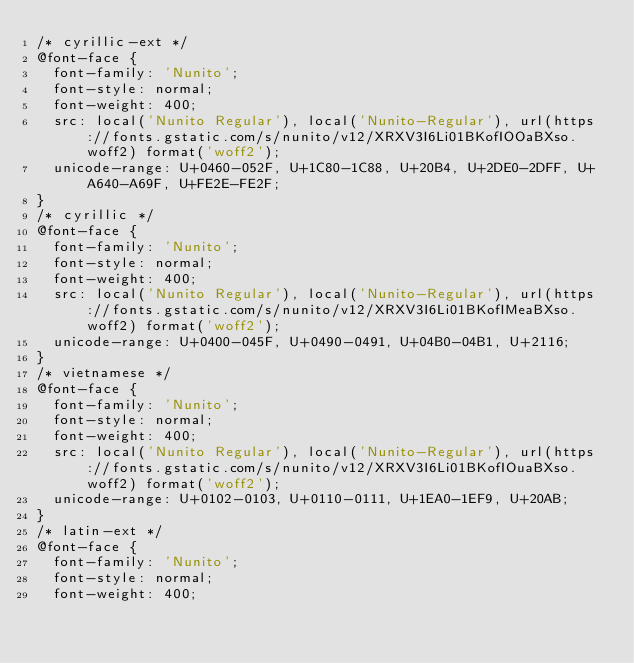Convert code to text. <code><loc_0><loc_0><loc_500><loc_500><_CSS_>/* cyrillic-ext */
@font-face {
  font-family: 'Nunito';
  font-style: normal;
  font-weight: 400;
  src: local('Nunito Regular'), local('Nunito-Regular'), url(https://fonts.gstatic.com/s/nunito/v12/XRXV3I6Li01BKofIOOaBXso.woff2) format('woff2');
  unicode-range: U+0460-052F, U+1C80-1C88, U+20B4, U+2DE0-2DFF, U+A640-A69F, U+FE2E-FE2F;
}
/* cyrillic */
@font-face {
  font-family: 'Nunito';
  font-style: normal;
  font-weight: 400;
  src: local('Nunito Regular'), local('Nunito-Regular'), url(https://fonts.gstatic.com/s/nunito/v12/XRXV3I6Li01BKofIMeaBXso.woff2) format('woff2');
  unicode-range: U+0400-045F, U+0490-0491, U+04B0-04B1, U+2116;
}
/* vietnamese */
@font-face {
  font-family: 'Nunito';
  font-style: normal;
  font-weight: 400;
  src: local('Nunito Regular'), local('Nunito-Regular'), url(https://fonts.gstatic.com/s/nunito/v12/XRXV3I6Li01BKofIOuaBXso.woff2) format('woff2');
  unicode-range: U+0102-0103, U+0110-0111, U+1EA0-1EF9, U+20AB;
}
/* latin-ext */
@font-face {
  font-family: 'Nunito';
  font-style: normal;
  font-weight: 400;</code> 